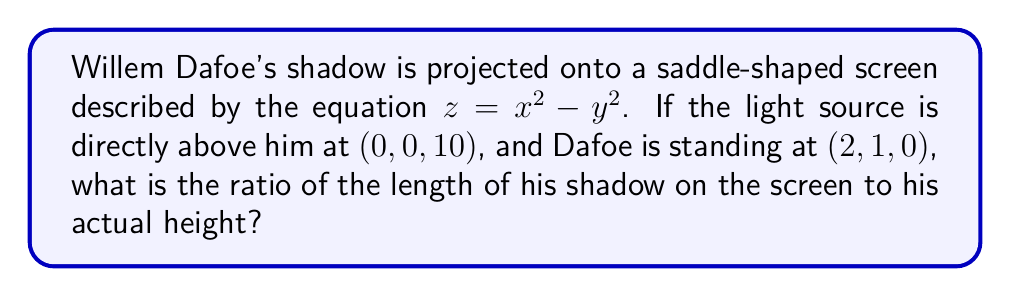Help me with this question. To solve this problem, we'll follow these steps:

1) First, we need to find the point where Dafoe's shadow intersects the screen. This is where the line from the light source through Dafoe intersects the saddle surface.

2) The parametric equations of this line are:
   $x = 2t$
   $y = t$
   $z = 10(1-t)$

3) Substituting these into the equation of the saddle surface:
   $10(1-t) = (2t)^2 - t^2$
   $10 - 10t = 4t^2 - t^2$
   $10 - 10t = 3t^2$
   $3t^2 + 10t - 10 = 0$

4) Solving this quadratic equation:
   $t = \frac{-10 \pm \sqrt{100 + 120}}{6} = \frac{-10 \pm \sqrt{220}}{6}$
   We take the positive solution as t must be between 0 and 1.
   $t = \frac{-10 + \sqrt{220}}{6} \approx 0.8028$

5) The shadow point is thus approximately at:
   $(1.6056, 0.8028, 1.9718)$

6) The distance from Dafoe to this point is:
   $\sqrt{(1.6056-2)^2 + (0.8028-1)^2 + 1.9718^2} \approx 2.2377$

7) Dafoe's actual height is the distance from (2, 1, 0) to (2, 1, 10), which is 10.

8) The ratio of shadow length to actual height is thus:
   $\frac{2.2377}{10} \approx 0.2238$
Answer: 0.2238 